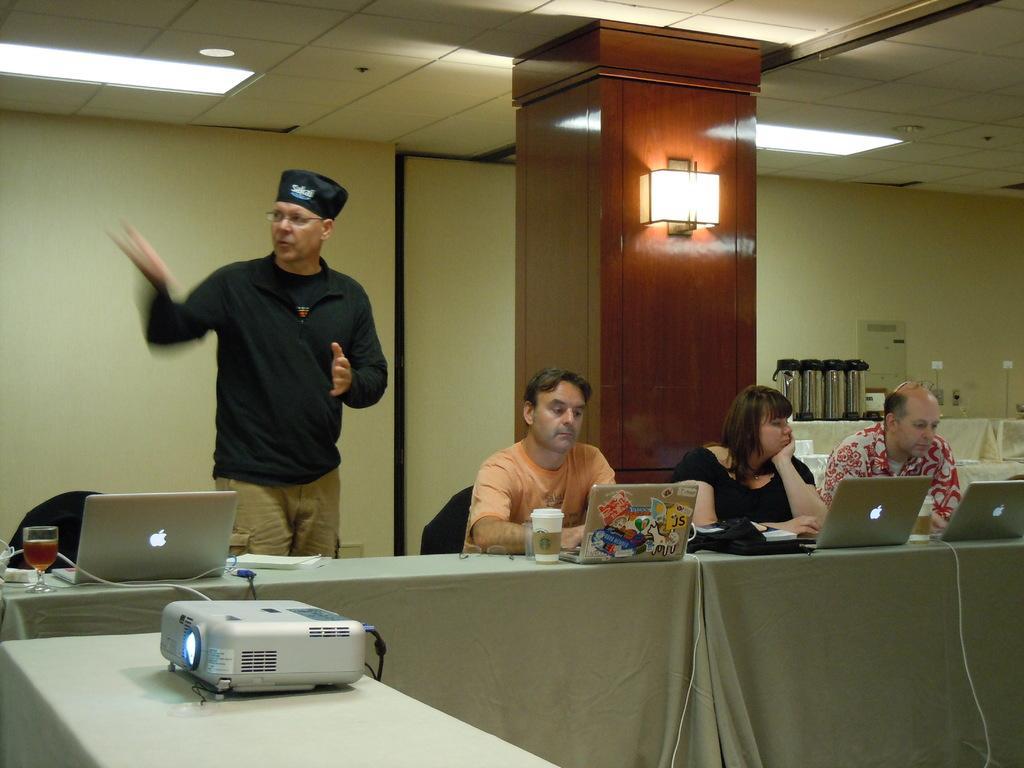Please provide a concise description of this image. In this image there are group of persons who are sitting and standing in front of them there are laptops,coffee cups,wine glasses and at the bottom left of the image there is a projector at the background of the image there is a wall. 